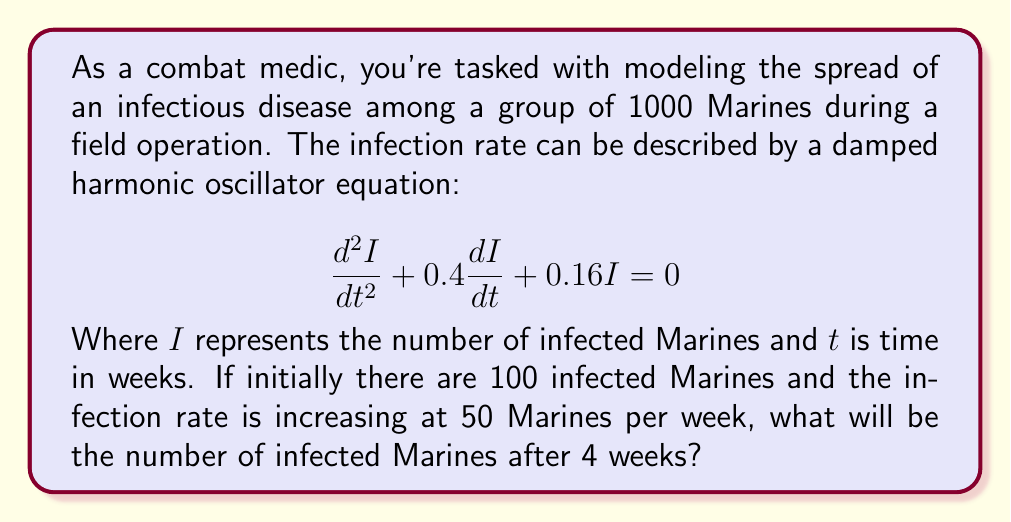What is the answer to this math problem? To solve this problem, we need to follow these steps:

1) The general solution for a damped harmonic oscillator equation of the form:
   $$\frac{d^2I}{dt^2} + 2\beta\frac{dI}{dt} + \omega_0^2I = 0$$
   is given by:
   $$I(t) = e^{-\beta t}(A\cos(\omega t) + B\sin(\omega t))$$
   where $\omega = \sqrt{\omega_0^2 - \beta^2}$

2) In our case, $2\beta = 0.4$ and $\omega_0^2 = 0.16$. So:
   $\beta = 0.2$ and $\omega_0 = 0.4$

3) Calculate $\omega$:
   $$\omega = \sqrt{0.4^2 - 0.2^2} = \sqrt{0.12} \approx 0.3464$$

4) Our general solution is:
   $$I(t) = e^{-0.2t}(A\cos(0.3464t) + B\sin(0.3464t))$$

5) We need to find A and B using initial conditions:
   At $t=0$, $I(0) = 100$ and $I'(0) = 50$

6) From $I(0) = 100$:
   $$100 = A$$

7) From $I'(0) = 50$:
   $$50 = -0.2A + 0.3464B$$
   $$50 = -20 + 0.3464B$$
   $$B \approx 202.37$$

8) Our specific solution is:
   $$I(t) = e^{-0.2t}(100\cos(0.3464t) + 202.37\sin(0.3464t))$$

9) To find the number of infected Marines after 4 weeks, we substitute $t=4$:
   $$I(4) = e^{-0.2(4)}(100\cos(0.3464(4)) + 202.37\sin(0.3464(4)))$$
   $$I(4) \approx 0.4493(100(-0.1118) + 202.37(0.9937))$$
   $$I(4) \approx 89.85$$

10) Rounding to the nearest whole number, as we can't have a fractional number of infected Marines:
    $$I(4) \approx 90$$
Answer: After 4 weeks, approximately 90 Marines will be infected. 